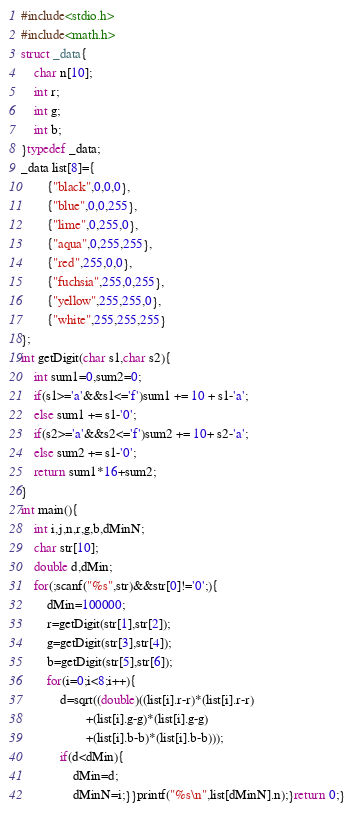Convert code to text. <code><loc_0><loc_0><loc_500><loc_500><_C_>#include<stdio.h>
#include<math.h>
struct _data{
	char n[10];
	int r;
	int g;
	int b;
}typedef _data;
_data list[8]={
		{"black",0,0,0},
		{"blue",0,0,255},
		{"lime",0,255,0},
		{"aqua",0,255,255},
		{"red",255,0,0},
		{"fuchsia",255,0,255},
		{"yellow",255,255,0},
		{"white",255,255,255}
};
int getDigit(char s1,char s2){
	int sum1=0,sum2=0;
	if(s1>='a'&&s1<='f')sum1 += 10 + s1-'a';
	else sum1 += s1-'0';
	if(s2>='a'&&s2<='f')sum2 += 10+ s2-'a';
	else sum2 += s1-'0';
	return sum1*16+sum2;
}
int main(){
	int i,j,n,r,g,b,dMinN;
	char str[10];
	double d,dMin;
	for(;scanf("%s",str)&&str[0]!='0';){
		dMin=100000;
		r=getDigit(str[1],str[2]);
		g=getDigit(str[3],str[4]);
		b=getDigit(str[5],str[6]);
		for(i=0;i<8;i++){
			d=sqrt((double)((list[i].r-r)*(list[i].r-r)
					+(list[i].g-g)*(list[i].g-g)
					+(list[i].b-b)*(list[i].b-b)));
			if(d<dMin){
				dMin=d;
				dMinN=i;}}printf("%s\n",list[dMinN].n);}return 0;}</code> 